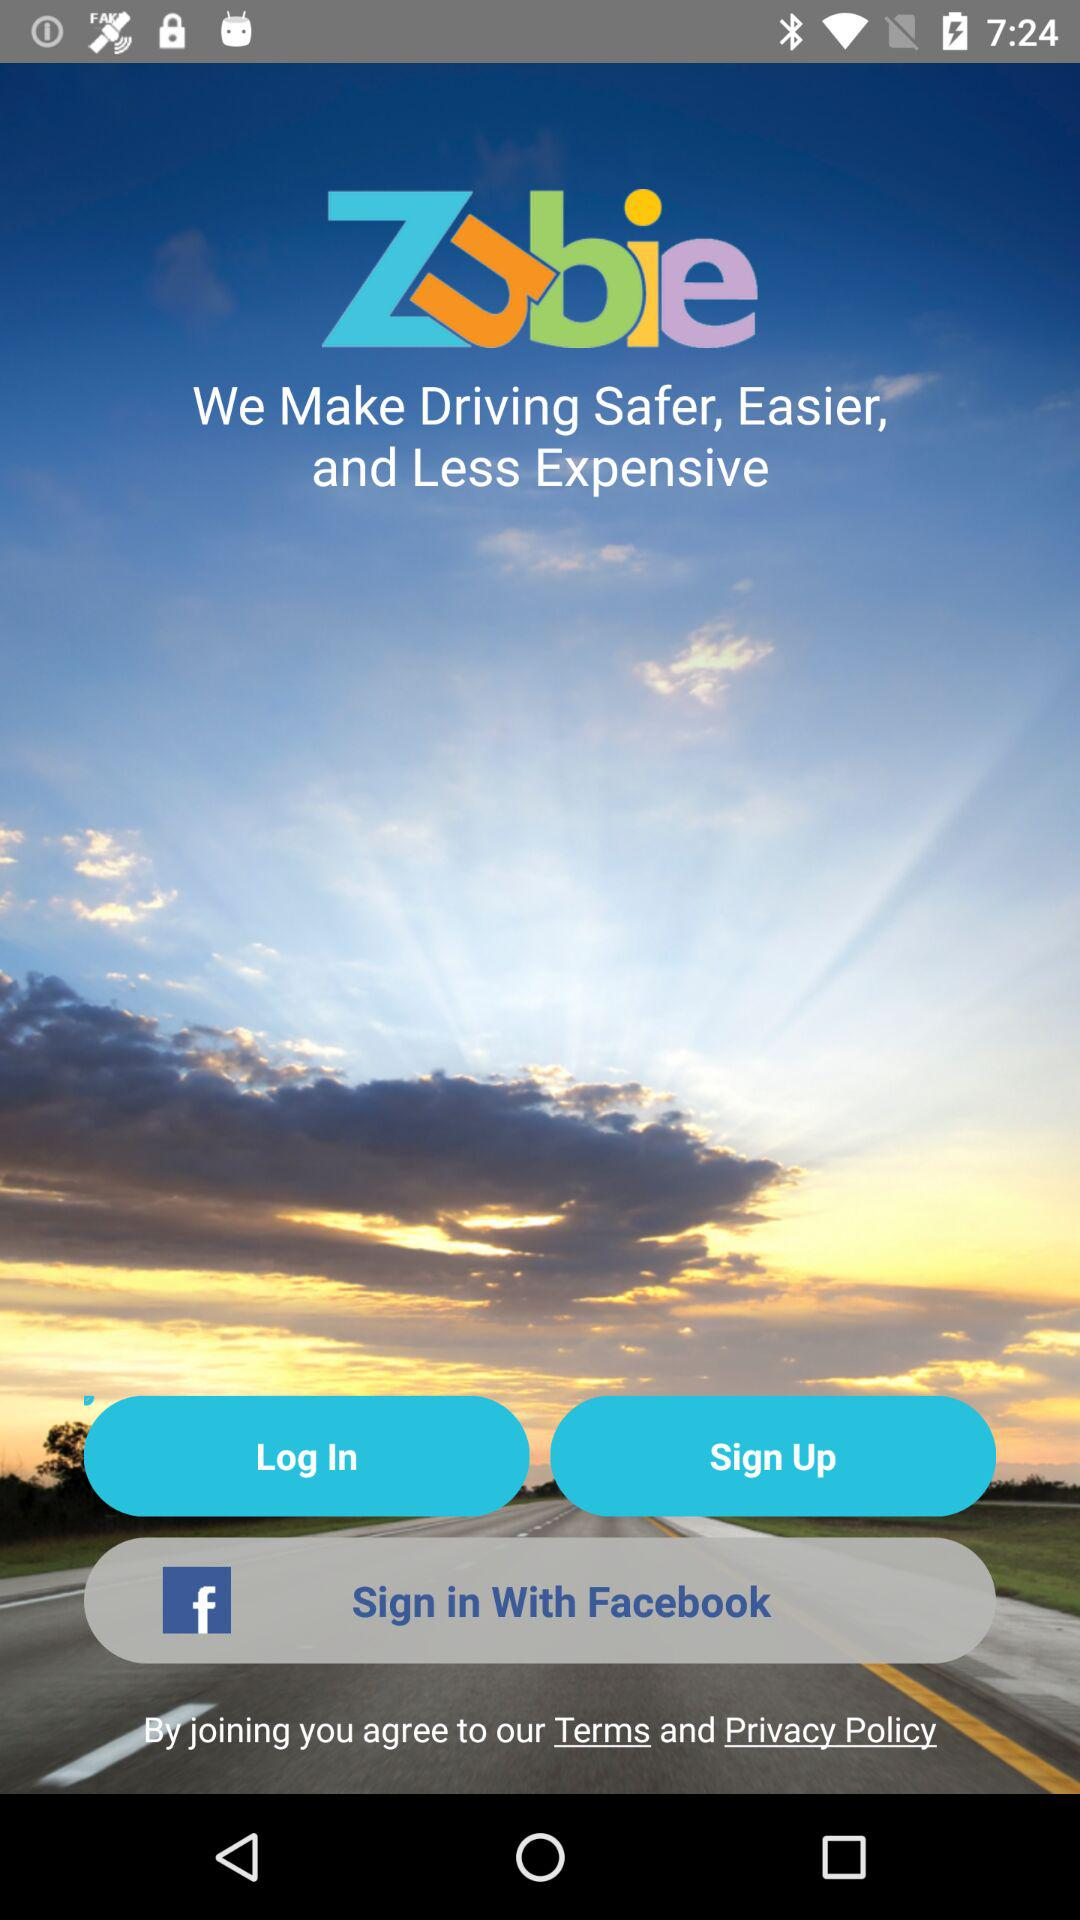How can we sign up? You can sign up with "Facebook". 